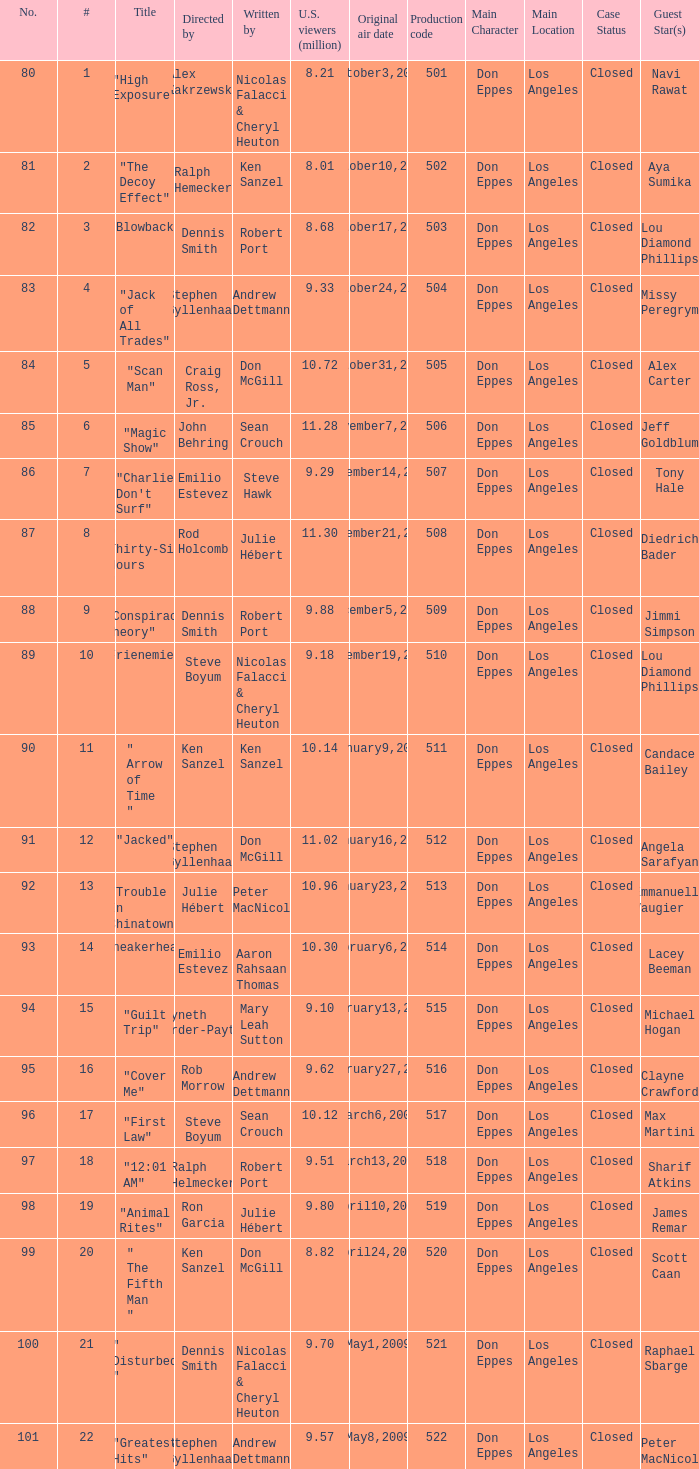How many times did episode 6 originally air? 1.0. 